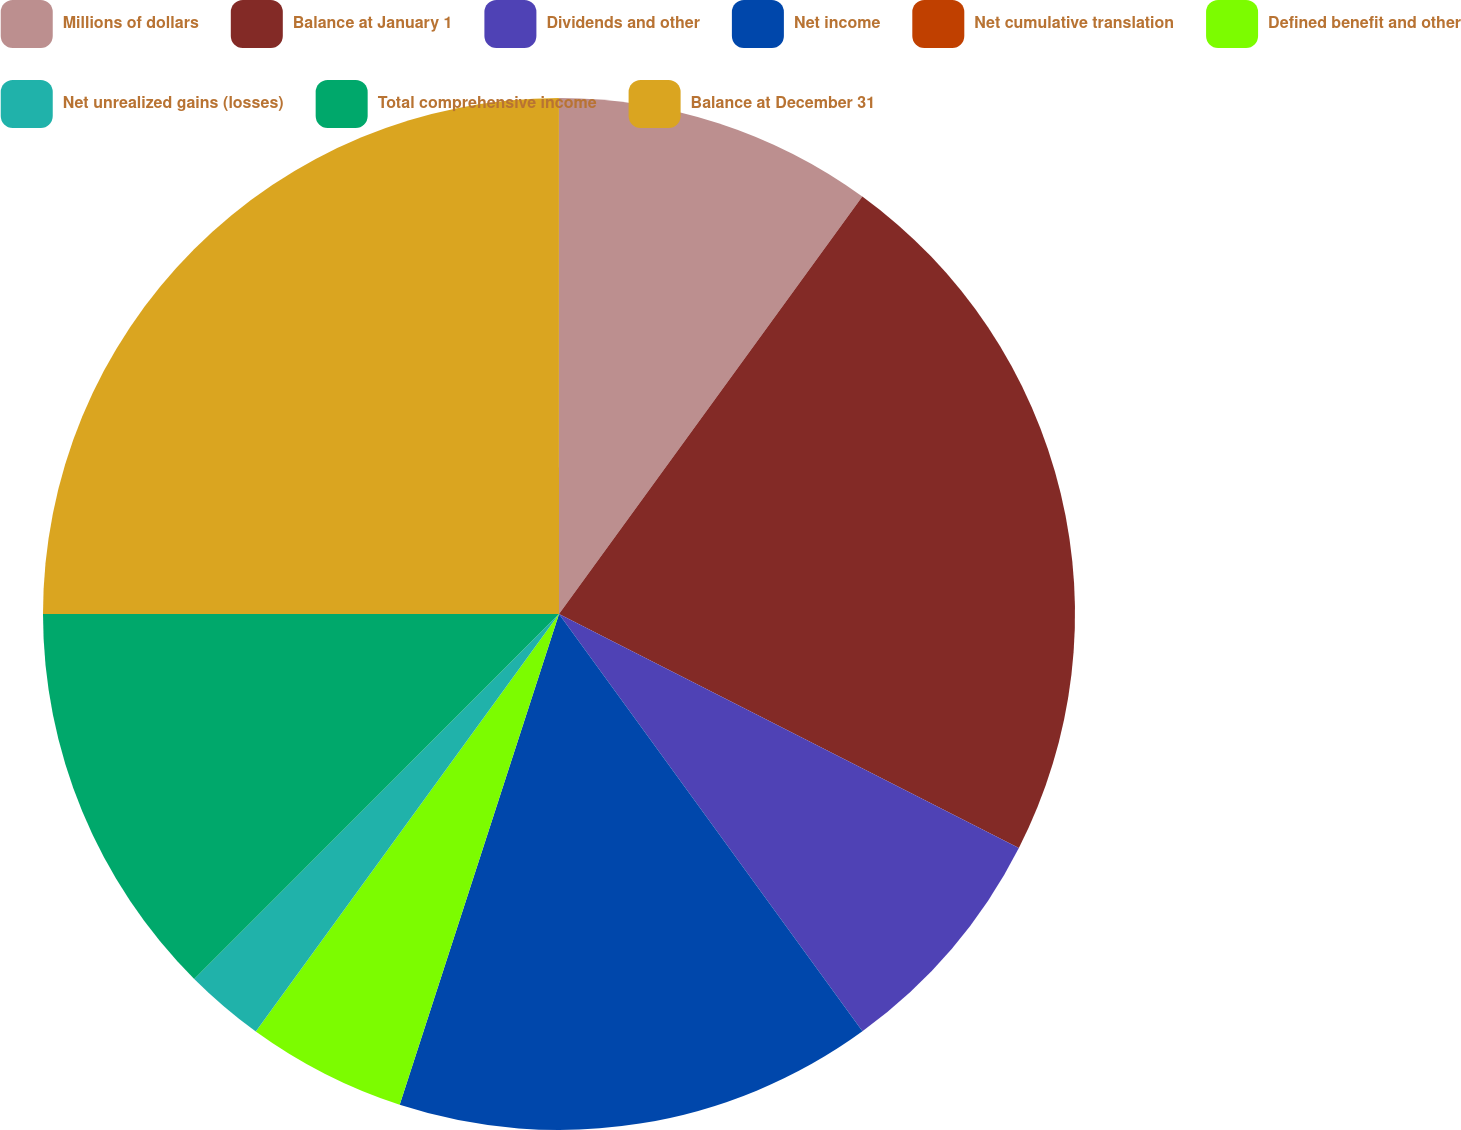Convert chart. <chart><loc_0><loc_0><loc_500><loc_500><pie_chart><fcel>Millions of dollars<fcel>Balance at January 1<fcel>Dividends and other<fcel>Net income<fcel>Net cumulative translation<fcel>Defined benefit and other<fcel>Net unrealized gains (losses)<fcel>Total comprehensive income<fcel>Balance at December 31<nl><fcel>10.0%<fcel>22.49%<fcel>7.5%<fcel>15.0%<fcel>0.0%<fcel>5.0%<fcel>2.5%<fcel>12.5%<fcel>25.0%<nl></chart> 